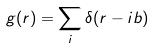Convert formula to latex. <formula><loc_0><loc_0><loc_500><loc_500>g ( r ) = \sum _ { i } \delta ( r - i b )</formula> 